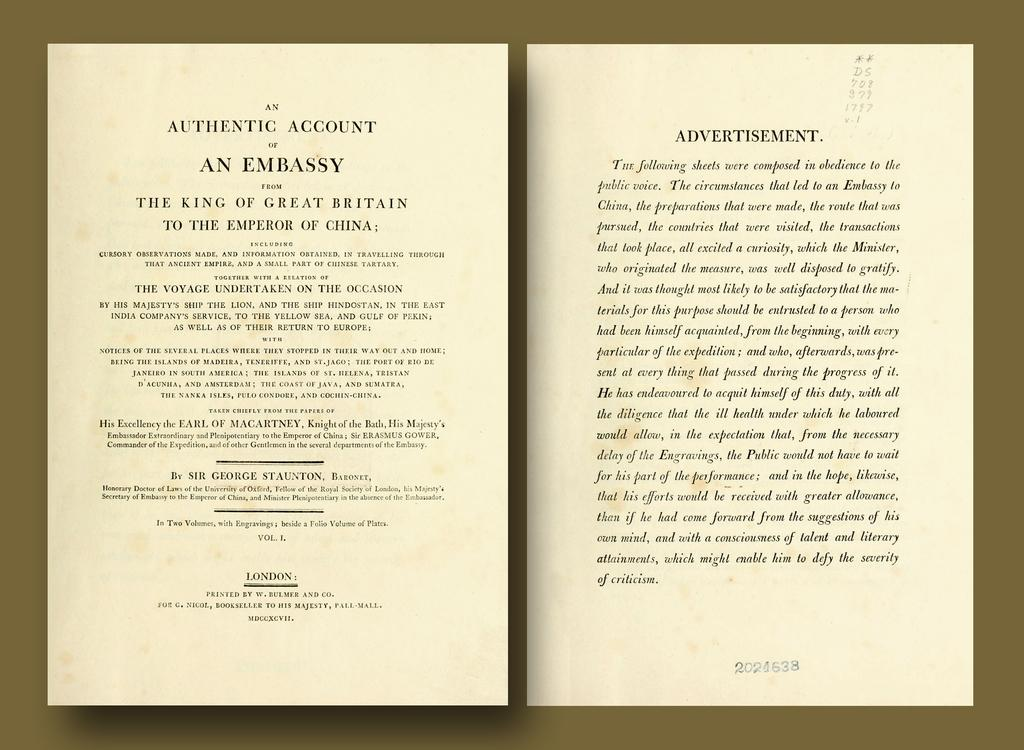<image>
Describe the image concisely. Book opened on a page with the words "Authentic Account" on top. 